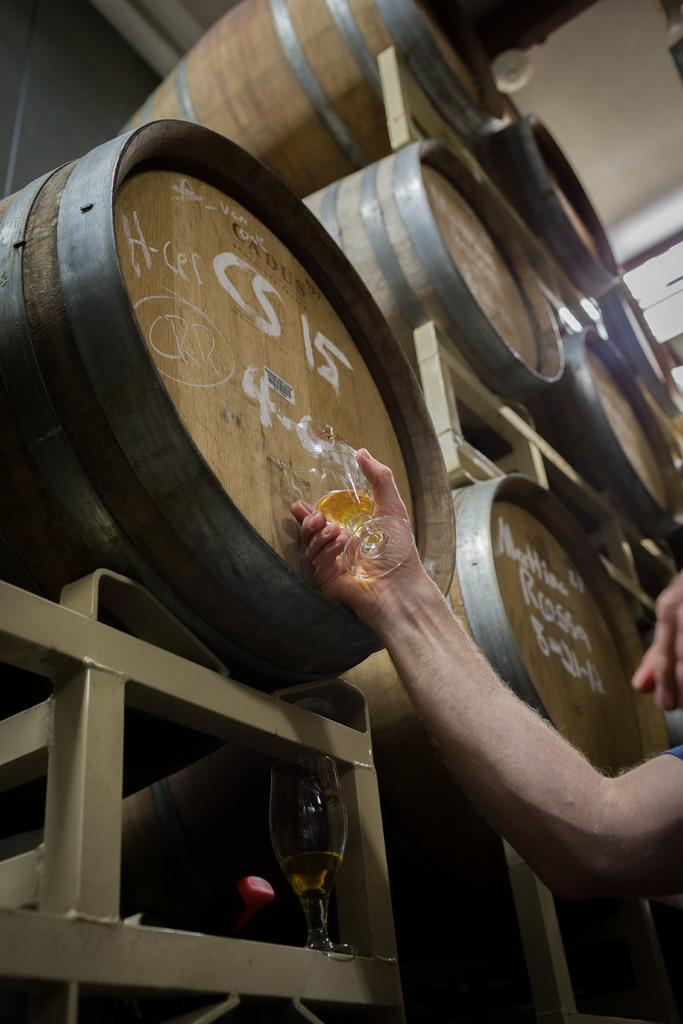<image>
Describe the image concisely. Snifter being filled from a barrel with the label CS 15 on it, while empty snifter sits below barrel after having been 1/7th filled. 